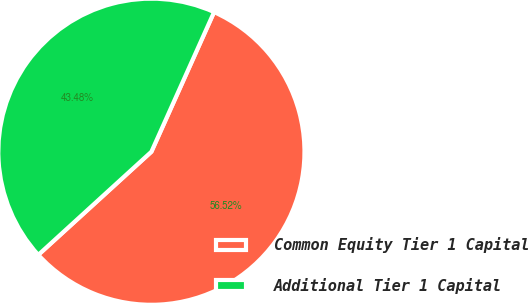Convert chart. <chart><loc_0><loc_0><loc_500><loc_500><pie_chart><fcel>Common Equity Tier 1 Capital<fcel>Additional Tier 1 Capital<nl><fcel>56.52%<fcel>43.48%<nl></chart> 